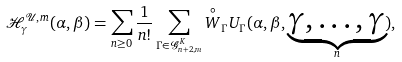<formula> <loc_0><loc_0><loc_500><loc_500>\mathcal { H } _ { \gamma } ^ { \mathcal { U } , m } ( \alpha , \beta ) = \sum _ { n \geq 0 } \frac { 1 } { n ! } \sum _ { \Gamma \in \mathcal { G } ^ { K } _ { n + 2 , m } } \overset { \circ } { W } _ { \Gamma } U _ { \Gamma } ( \alpha , \beta , \underset { n } { \underbrace { \gamma , \dots , \gamma } } ) ,</formula> 